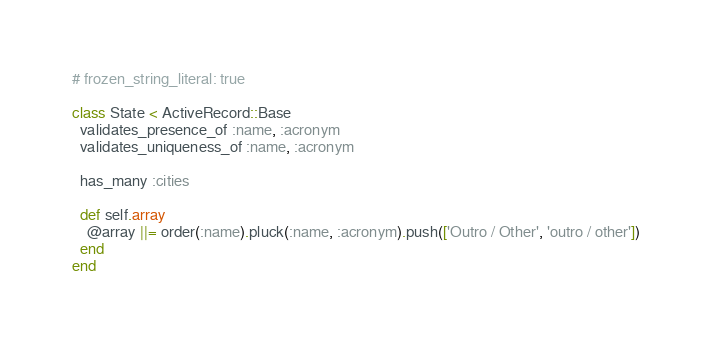<code> <loc_0><loc_0><loc_500><loc_500><_Ruby_># frozen_string_literal: true

class State < ActiveRecord::Base
  validates_presence_of :name, :acronym
  validates_uniqueness_of :name, :acronym

  has_many :cities

  def self.array
    @array ||= order(:name).pluck(:name, :acronym).push(['Outro / Other', 'outro / other'])
  end
end
</code> 